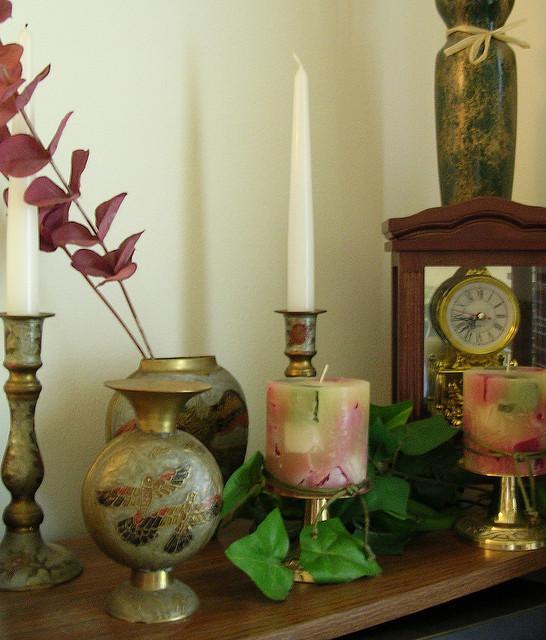How many vases are in the picture?
Give a very brief answer. 3. 